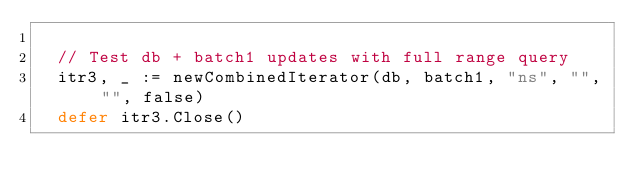<code> <loc_0><loc_0><loc_500><loc_500><_Go_>
	// Test db + batch1 updates with full range query
	itr3, _ := newCombinedIterator(db, batch1, "ns", "", "", false)
	defer itr3.Close()</code> 